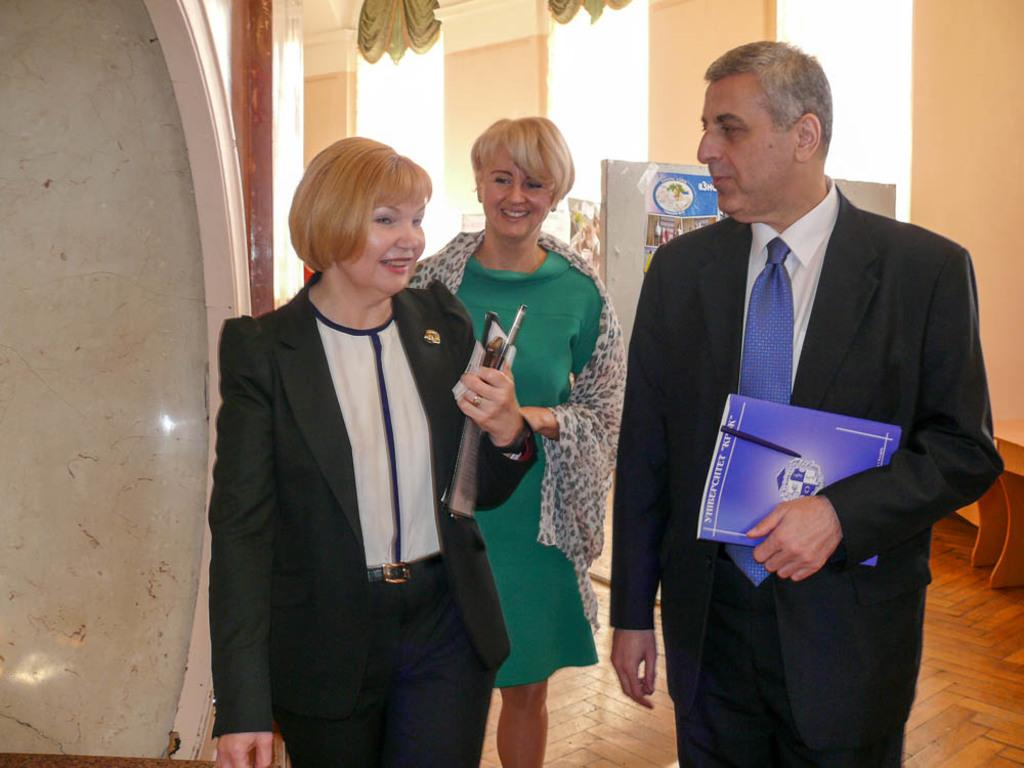How many people are in the image? There are two people in the image, a man and a woman. What are the man and woman doing in the image? Both the man and man and woman are standing on the floor and holding books in their hands. What can be seen in the background of the image? There are advertisement boards and windows in the background of the image. What type of oil is being used by the man and woman in the image? There is no oil present in the image; the man and woman are holding books. What disease is the woman suffering from in the image? There is no indication of any disease in the image; the woman is simply standing and holding a book. 